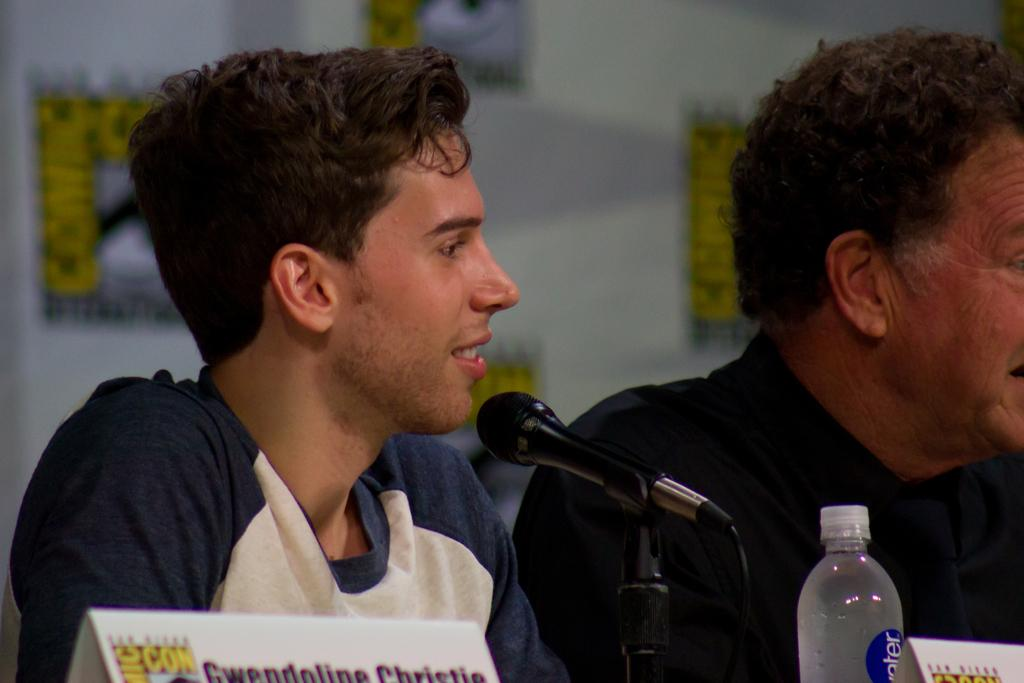How many people are in the image? There are two men in the image. What is the facial expression of one of the men? One of the men is smiling. What is the smiling man doing in the image? The smiling man is in front of a microphone. What objects can be seen in the image related to identification? There are two name boards in the image. What type of container is visible in the image? There is a bottle in the image. What can be seen in the background of the image? There is a banner visible in the background of the image. What type of corn is being folded by the engine in the image? There is no corn or engine present in the image. 